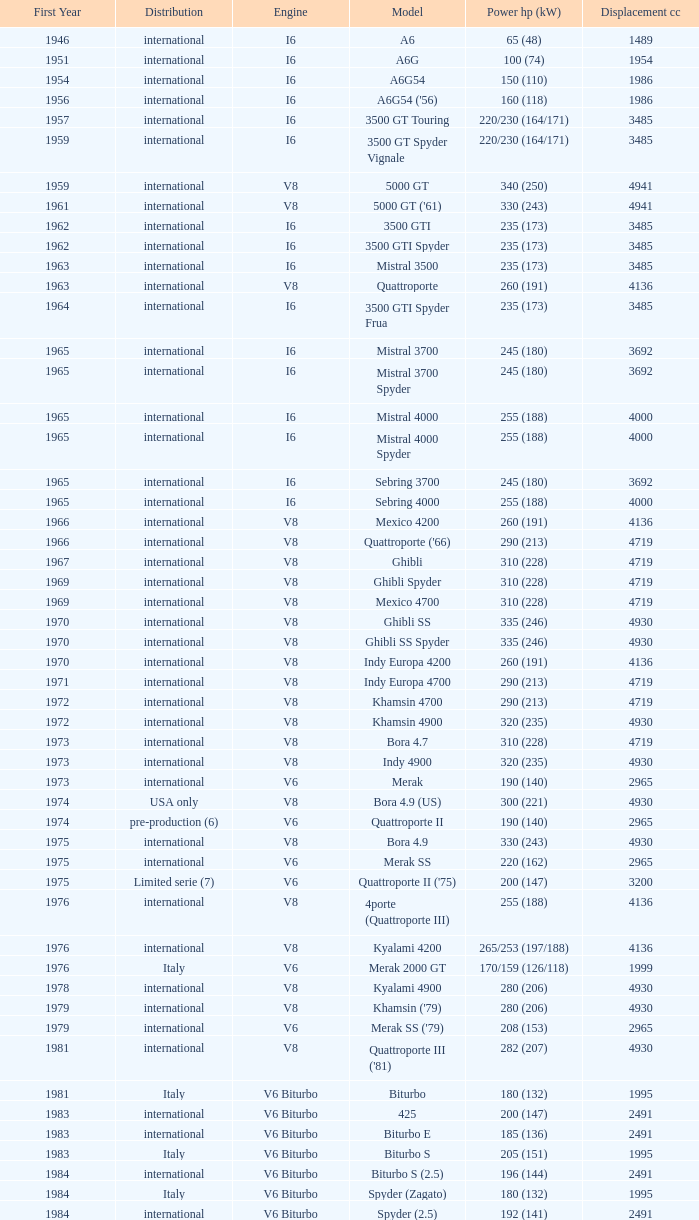What is the lowest First Year, when Model is "Quattroporte (2.8)"? 1994.0. Can you parse all the data within this table? {'header': ['First Year', 'Distribution', 'Engine', 'Model', 'Power hp (kW)', 'Displacement cc'], 'rows': [['1946', 'international', 'I6', 'A6', '65 (48)', '1489'], ['1951', 'international', 'I6', 'A6G', '100 (74)', '1954'], ['1954', 'international', 'I6', 'A6G54', '150 (110)', '1986'], ['1956', 'international', 'I6', "A6G54 ('56)", '160 (118)', '1986'], ['1957', 'international', 'I6', '3500 GT Touring', '220/230 (164/171)', '3485'], ['1959', 'international', 'I6', '3500 GT Spyder Vignale', '220/230 (164/171)', '3485'], ['1959', 'international', 'V8', '5000 GT', '340 (250)', '4941'], ['1961', 'international', 'V8', "5000 GT ('61)", '330 (243)', '4941'], ['1962', 'international', 'I6', '3500 GTI', '235 (173)', '3485'], ['1962', 'international', 'I6', '3500 GTI Spyder', '235 (173)', '3485'], ['1963', 'international', 'I6', 'Mistral 3500', '235 (173)', '3485'], ['1963', 'international', 'V8', 'Quattroporte', '260 (191)', '4136'], ['1964', 'international', 'I6', '3500 GTI Spyder Frua', '235 (173)', '3485'], ['1965', 'international', 'I6', 'Mistral 3700', '245 (180)', '3692'], ['1965', 'international', 'I6', 'Mistral 3700 Spyder', '245 (180)', '3692'], ['1965', 'international', 'I6', 'Mistral 4000', '255 (188)', '4000'], ['1965', 'international', 'I6', 'Mistral 4000 Spyder', '255 (188)', '4000'], ['1965', 'international', 'I6', 'Sebring 3700', '245 (180)', '3692'], ['1965', 'international', 'I6', 'Sebring 4000', '255 (188)', '4000'], ['1966', 'international', 'V8', 'Mexico 4200', '260 (191)', '4136'], ['1966', 'international', 'V8', "Quattroporte ('66)", '290 (213)', '4719'], ['1967', 'international', 'V8', 'Ghibli', '310 (228)', '4719'], ['1969', 'international', 'V8', 'Ghibli Spyder', '310 (228)', '4719'], ['1969', 'international', 'V8', 'Mexico 4700', '310 (228)', '4719'], ['1970', 'international', 'V8', 'Ghibli SS', '335 (246)', '4930'], ['1970', 'international', 'V8', 'Ghibli SS Spyder', '335 (246)', '4930'], ['1970', 'international', 'V8', 'Indy Europa 4200', '260 (191)', '4136'], ['1971', 'international', 'V8', 'Indy Europa 4700', '290 (213)', '4719'], ['1972', 'international', 'V8', 'Khamsin 4700', '290 (213)', '4719'], ['1972', 'international', 'V8', 'Khamsin 4900', '320 (235)', '4930'], ['1973', 'international', 'V8', 'Bora 4.7', '310 (228)', '4719'], ['1973', 'international', 'V8', 'Indy 4900', '320 (235)', '4930'], ['1973', 'international', 'V6', 'Merak', '190 (140)', '2965'], ['1974', 'USA only', 'V8', 'Bora 4.9 (US)', '300 (221)', '4930'], ['1974', 'pre-production (6)', 'V6', 'Quattroporte II', '190 (140)', '2965'], ['1975', 'international', 'V8', 'Bora 4.9', '330 (243)', '4930'], ['1975', 'international', 'V6', 'Merak SS', '220 (162)', '2965'], ['1975', 'Limited serie (7)', 'V6', "Quattroporte II ('75)", '200 (147)', '3200'], ['1976', 'international', 'V8', '4porte (Quattroporte III)', '255 (188)', '4136'], ['1976', 'international', 'V8', 'Kyalami 4200', '265/253 (197/188)', '4136'], ['1976', 'Italy', 'V6', 'Merak 2000 GT', '170/159 (126/118)', '1999'], ['1978', 'international', 'V8', 'Kyalami 4900', '280 (206)', '4930'], ['1979', 'international', 'V8', "Khamsin ('79)", '280 (206)', '4930'], ['1979', 'international', 'V6', "Merak SS ('79)", '208 (153)', '2965'], ['1981', 'international', 'V8', "Quattroporte III ('81)", '282 (207)', '4930'], ['1981', 'Italy', 'V6 Biturbo', 'Biturbo', '180 (132)', '1995'], ['1983', 'international', 'V6 Biturbo', '425', '200 (147)', '2491'], ['1983', 'international', 'V6 Biturbo', 'Biturbo E', '185 (136)', '2491'], ['1983', 'Italy', 'V6 Biturbo', 'Biturbo S', '205 (151)', '1995'], ['1984', 'international', 'V6 Biturbo', 'Biturbo S (2.5)', '196 (144)', '2491'], ['1984', 'Italy', 'V6 Biturbo', 'Spyder (Zagato)', '180 (132)', '1995'], ['1984', 'international', 'V6 Biturbo', 'Spyder (2.5)', '192 (141)', '2491'], ['1985', 'Italy', 'V6 Biturbo', '420', '180 (132)', '1995'], ['1985', 'Italy', 'V6 Biturbo', 'Biturbo (II)', '180 (132)', '1995'], ['1985', 'international', 'V6 Biturbo', 'Biturbo E (II 2.5)', '185 (136)', '2491'], ['1985', 'Italy', 'V6 Biturbo', 'Biturbo S (II)', '210 (154)', '1995'], ['1986', 'international', 'V6 Biturbo', '228 (228i)', '250 (184)', '2790'], ['1986', 'international', 'V6 Biturbo', '228 (228i) Kat', '225 (165)', '2790'], ['1986', 'Italy', 'V6 Biturbo', '420i', '190 (140)', '1995'], ['1986', 'Italy', 'V6 Biturbo', '420 S', '210 (154)', '1995'], ['1986', 'Italy', 'V6 Biturbo', 'Biturbo i', '185 (136)', '1995'], ['1986', 'international', 'V8', 'Quattroporte Royale (III)', '300 (221)', '4930'], ['1986', 'international', 'V6 Biturbo', 'Spyder i', '185 (136)', '1996'], ['1987', 'international', 'V6 Biturbo', '430', '225 (165)', '2790'], ['1987', 'international', 'V6 Biturbo', '425i', '188 (138)', '2491'], ['1987', 'Italy', 'V6 Biturbo', 'Biturbo Si', '220 (162)', '1995'], ['1987', 'international', 'V6 Biturbo', 'Biturbo Si (2.5)', '188 (138)', '2491'], ['1987', 'international', 'V6 Biturbo', "Spyder i ('87)", '195 (143)', '1996'], ['1988', 'Italy', 'V6 Biturbo', '222', '220 (162)', '1996'], ['1988', 'Italy', 'V6 Biturbo', '422', '220 (162)', '1996'], ['1988', 'Italy (probably)', 'V6 Biturbo', '2.24V', '245 (180)', '1996'], ['1988', 'international', 'V6 Biturbo', '222 4v', '279 (205)', '2790'], ['1988', 'international', 'V6 Biturbo', '222 E', '225 (165)', '2790'], ['1988', 'international', 'V6 Biturbo', 'Karif', '285 (210)', '2790'], ['1988', 'international', 'V6 Biturbo', 'Karif (kat)', '248 (182)', '2790'], ['1988', 'international', 'V6 Biturbo', 'Karif (kat II)', '225 (165)', '2790'], ['1988', 'international', 'V6 Biturbo', 'Spyder i (2.5)', '188 (138)', '2491'], ['1989', 'international', 'V6 Biturbo', 'Spyder i (2.8)', '250 (184)', '2790'], ['1989', 'international', 'V6 Biturbo', 'Spyder i (2.8, kat)', '225 (165)', '2790'], ['1989', 'Italy', 'V6 Biturbo', "Spyder i ('90)", '220 (162)', '1996'], ['1990', 'international', 'V6 Biturbo', '222 SE', '250 (184)', '2790'], ['1990', 'international', 'V6 Biturbo', '222 SE (kat)', '225 (165)', '2790'], ['1990', 'Italy', 'V6 Biturbo', '4.18v', '220 (162)', '1995'], ['1990', 'Italy (probably)', 'V6 Biturbo', '4.24v', '245 (180)', '1996'], ['1990', 'international', 'V8 Biturbo', 'Shamal', '326 (240)', '3217'], ['1991', 'Italy', 'V6 Biturbo', '2.24v II', '245 (180)', '1996'], ['1991', 'international (probably)', 'V6 Biturbo', '2.24v II (kat)', '240 (176)', '1996'], ['1991', 'international', 'V6 Biturbo', '222 SR', '225 (165)', '2790'], ['1991', 'Italy (probably)', 'V6 Biturbo', '4.24v II (kat)', '240 (176)', '1996'], ['1991', 'international', 'V6 Biturbo', '430 4v', '279 (205)', '2790'], ['1991', 'Italy', 'V6 Biturbo', 'Racing', '283 (208)', '1996'], ['1991', 'Italy', 'V6 Biturbo', 'Spyder III', '245 (180)', '1996'], ['1991', 'international', 'V6 Biturbo', 'Spyder III (2.8, kat)', '225 (165)', '2790'], ['1991', 'Italy', 'V6 Biturbo', 'Spyder III (kat)', '240 (176)', '1996'], ['1992', 'Prototype', 'V6 Biturbo', 'Barchetta Stradale', '306 (225)', '1996'], ['1992', 'Single, Conversion', 'V6 Biturbo', 'Barchetta Stradale 2.8', '284 (209)', '2790'], ['1992', 'Italy', 'V6 Biturbo', 'Ghibli II (2.0)', '306 (225)', '1996'], ['1993', 'international', 'V6 Biturbo', 'Ghibli II (2.8)', '284 (209)', '2790'], ['1994', 'Italy', 'V6 Biturbo', 'Quattroporte (2.0)', '287 (211)', '1996'], ['1994', 'international', 'V6 Biturbo', 'Quattroporte (2.8)', '284 (209)', '2790'], ['1995', 'international', 'V6 Biturbo', 'Ghibli Cup', '330 (243)', '1996'], ['1995', 'international', 'V8 Biturbo', 'Quattroporte Ottocilindri', '335 (246)', '3217'], ['1996', 'international', 'V6 Biturbo', 'Ghibli Primatist', '306 (225)', '1996'], ['1998', 'international', 'V8 Biturbo', '3200 GT', '370 (272)', '3217'], ['1998', 'international', 'V6 Biturbo', 'Quattroporte V6 Evoluzione', '284 (209)', '2790'], ['1998', 'international', 'V8 Biturbo', 'Quattroporte V8 Evoluzione', '335 (246)', '3217'], ['2000', 'international', 'V8 Biturbo', '3200 GTA', '368 (271)', '3217'], ['2001', 'international', 'V8', 'Spyder GT', '390 (287)', '4244'], ['2001', 'international', 'V8', 'Spyder CC', '390 (287)', '4244'], ['2001', 'international', 'V8', 'Coupé GT', '390 (287)', '4244'], ['2001', 'international', 'V8', 'Coupé CC', '390 (287)', '4244'], ['2002', 'international', 'V8', 'Gran Sport', '400 (294)', '4244'], ['2004', 'international', 'V8', 'Quattroporte V', '400 (294)', '4244'], ['2004', 'Limited', 'V12', 'MC12 (aka MCC)', '630 (463)', '5998'], ['2008', 'international', 'V8', 'GranTurismo', '405', '4244'], ['2010', 'international', 'V8', 'GranCabrio', '433', '4691']]} 